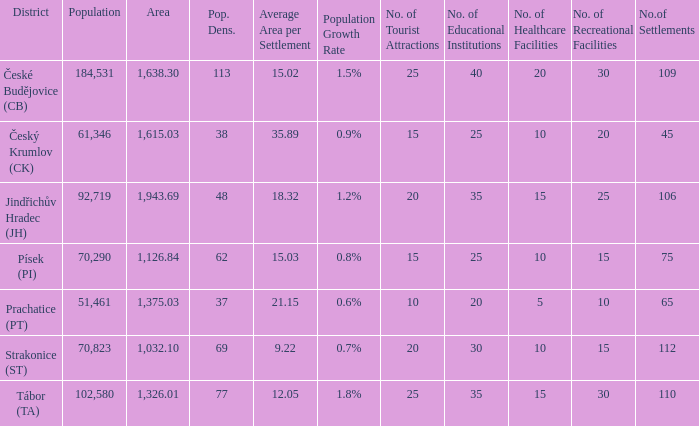What is the population with an area of 1,126.84? 70290.0. 